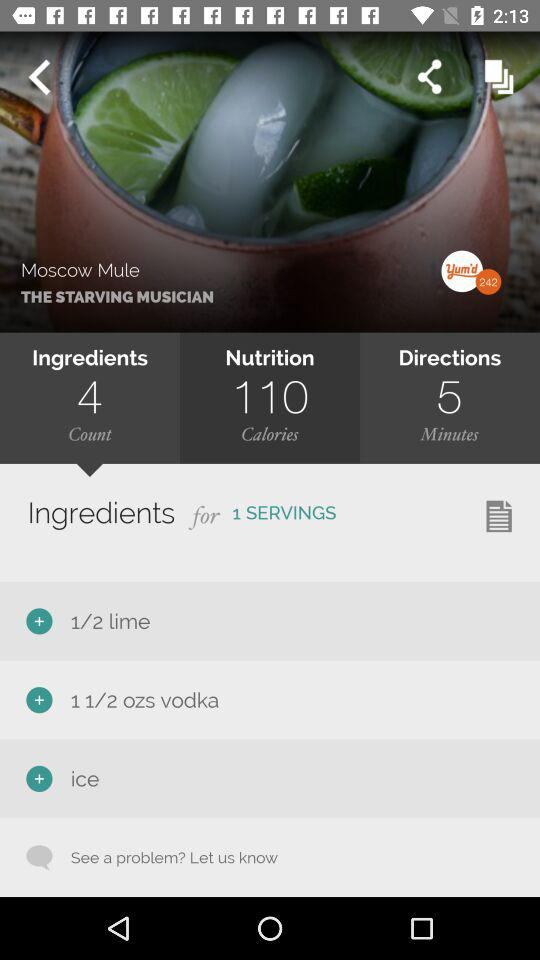How many calories are in this dish? There are 110 calories in this dish. 